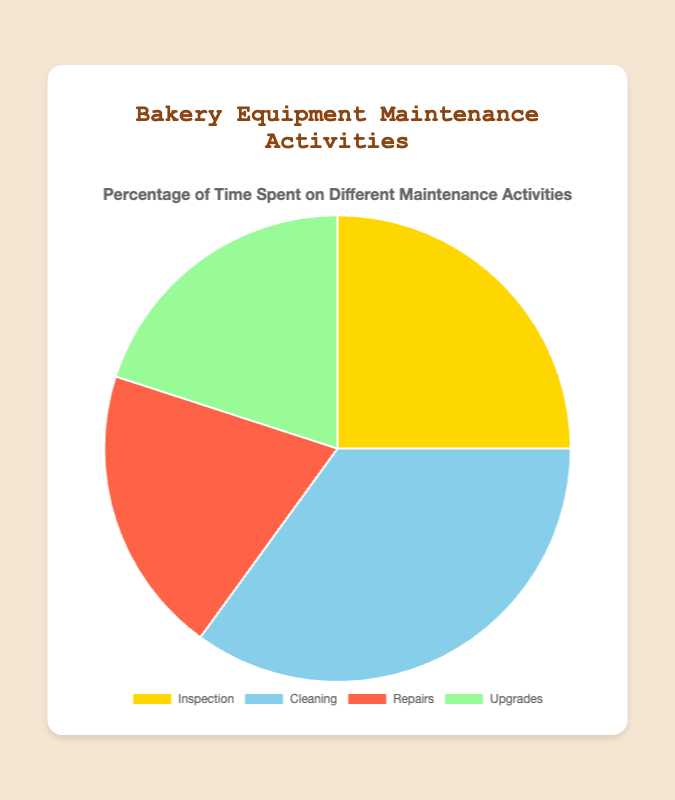Which maintenance activity takes up the largest percentage of time? By visibly inspecting the pie chart, it's clear that the largest slice corresponds to the 'Cleaning' activity with a value of 35%.
Answer: Cleaning How much more time is spent on Cleaning compared to Repairs? To find the difference, subtract the percentage of Repairs (20%) from the percentage of Cleaning (35%): 35% - 20% = 15%.
Answer: 15% What is the combined percentage of time spent on Repairs and Upgrades? Add the percentages for Repairs (20%) and Upgrades (20%): 20% + 20% = 40%.
Answer: 40% Which maintenance activities take up an equal percentage of time? On examining the pie chart, it shows that both 'Repairs' and 'Upgrades' have the same percentage value of 20%.
Answer: Repairs and Upgrades What is the total percentage of time spent on activities other than Inspection? Add the percentages of Cleaning (35%), Repairs (20%), and Upgrades (20%): 35% + 20% + 20% = 75%.
Answer: 75% Which activity slice is depicted with a gold color? By observing the color coding on the pie chart, it's clear that the gold color represents the 'Inspection' activity.
Answer: Inspection How much more time is spent on Cleaning compared to Inspection and Repairs combined? First, find the combined percentage for Inspection and Repairs: 25% + 20% = 45%. Then, subtract this combined value from Cleaning's percentage: 35% - 45% = -10%. Since the result is negative, it indicates that less time is spent on Cleaning than on Inspection and Repairs combined.
Answer: 10% more What is the average percentage of time spent on all maintenance activities? Calculate the average by summing the percentages and dividing by the number of activities: (25% + 35% + 20% + 20%) / 4 = 100% / 4 = 25%.
Answer: 25% Which activity has a similarly sized slice to Repairs? By comparing the slices visually, 'Upgrades' has a similarly sized slice to 'Repairs', both at 20%.
Answer: Upgrades What is the difference in the percentage of time spent on the activities with the highest and lowest percentages? Identify the highest (Cleaning at 35%) and the lowest (Repairs/Upgrades at 20%). Subtract the lowest from the highest: 35% - 20% = 15%.
Answer: 15% 